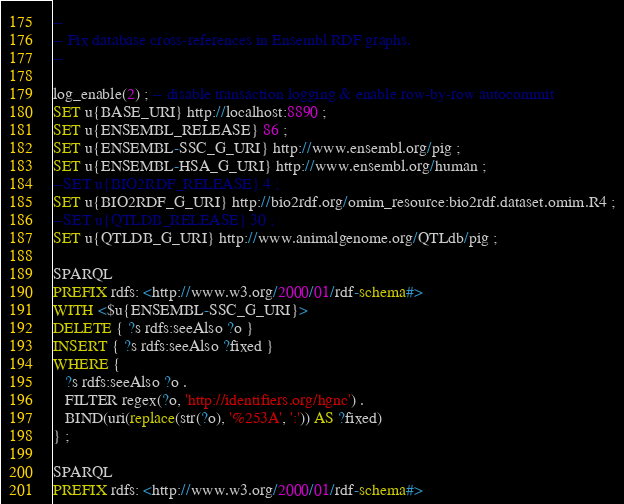Convert code to text. <code><loc_0><loc_0><loc_500><loc_500><_SQL_>-- 
-- Fix database cross-references in Ensembl RDF graphs.
--

log_enable(2) ; -- disable transaction logging & enable row-by-row autocommit
SET u{BASE_URI} http://localhost:8890 ;
SET u{ENSEMBL_RELEASE} 86 ;
SET u{ENSEMBL-SSC_G_URI} http://www.ensembl.org/pig ;
SET u{ENSEMBL-HSA_G_URI} http://www.ensembl.org/human ;
--SET u{BIO2RDF_RELEASE} 4 ;
SET u{BIO2RDF_G_URI} http://bio2rdf.org/omim_resource:bio2rdf.dataset.omim.R4 ;
--SET u{QTLDB_RELEASE} 30 ;
SET u{QTLDB_G_URI} http://www.animalgenome.org/QTLdb/pig ;

SPARQL
PREFIX rdfs: <http://www.w3.org/2000/01/rdf-schema#>
WITH <$u{ENSEMBL-SSC_G_URI}>
DELETE { ?s rdfs:seeAlso ?o }
INSERT { ?s rdfs:seeAlso ?fixed }
WHERE {
   ?s rdfs:seeAlso ?o .
   FILTER regex(?o, 'http://identifiers.org/hgnc') .
   BIND(uri(replace(str(?o), '%253A', ':')) AS ?fixed)
} ;

SPARQL
PREFIX rdfs: <http://www.w3.org/2000/01/rdf-schema#></code> 